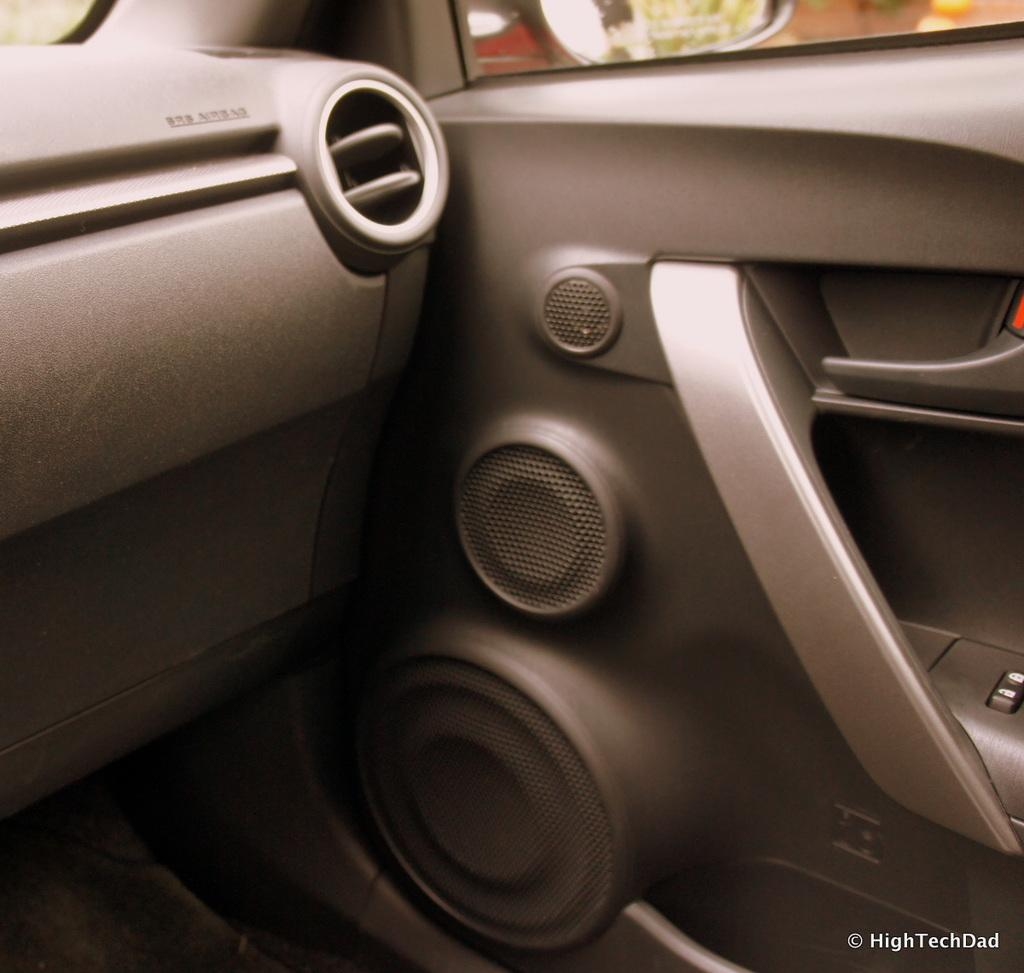Where was the image taken? The image is taken inside a car. What can be seen on the car door in the image? There are door speakers visible in the image. What part of the car is present in the image? The car door is present in the image. What type of window is visible at the top of the image? There is a glass window at the top of the image. What is used for reflection in the image? A mirror is visible at the top of the image. How many bells are hanging from the rearview mirror in the image? There are no bells hanging from the rearview mirror in the image. What type of bucket is visible in the image? There is no bucket present in the image. 